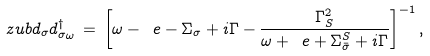<formula> <loc_0><loc_0><loc_500><loc_500>\ z u b { d _ { \sigma } } { d _ { \sigma } ^ { \dag } } _ { \omega } \, = \, \left [ \omega - \ e - \Sigma _ { \sigma } + i \Gamma - \frac { \Gamma _ { S } ^ { 2 } } { \omega + \ e + \Sigma _ { \bar { \sigma } } ^ { S } + i \Gamma } \right ] ^ { - 1 } ,</formula> 